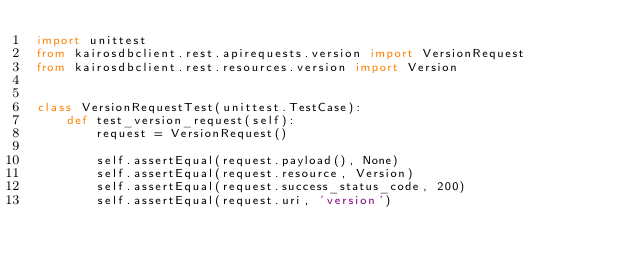Convert code to text. <code><loc_0><loc_0><loc_500><loc_500><_Python_>import unittest
from kairosdbclient.rest.apirequests.version import VersionRequest
from kairosdbclient.rest.resources.version import Version


class VersionRequestTest(unittest.TestCase):
    def test_version_request(self):
        request = VersionRequest()

        self.assertEqual(request.payload(), None)
        self.assertEqual(request.resource, Version)
        self.assertEqual(request.success_status_code, 200)
        self.assertEqual(request.uri, 'version')</code> 